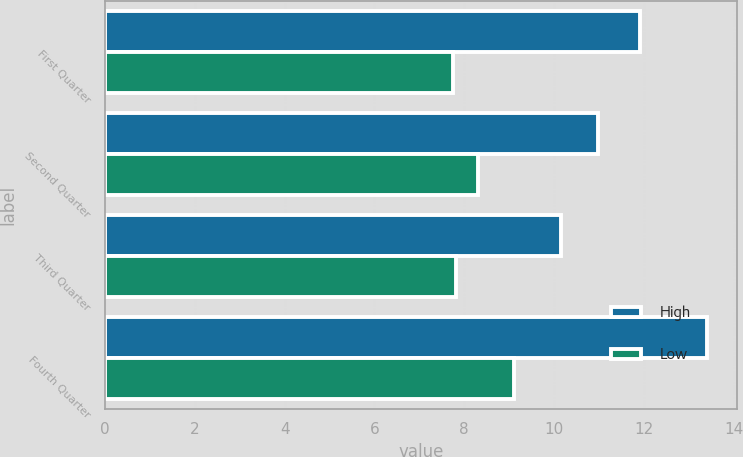Convert chart to OTSL. <chart><loc_0><loc_0><loc_500><loc_500><stacked_bar_chart><ecel><fcel>First Quarter<fcel>Second Quarter<fcel>Third Quarter<fcel>Fourth Quarter<nl><fcel>High<fcel>11.91<fcel>10.97<fcel>10.15<fcel>13.4<nl><fcel>Low<fcel>7.75<fcel>8.31<fcel>7.81<fcel>9.12<nl></chart> 